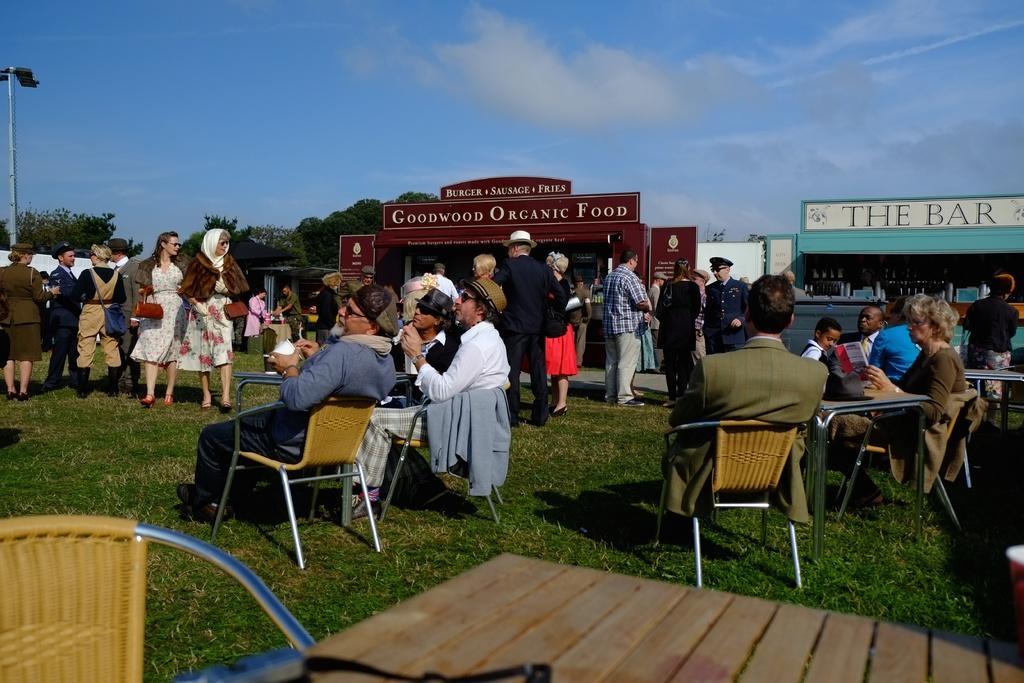How would you summarize this image in a sentence or two? In this picture we can see a group of people on the ground and few people are standing and few people are sitting on chairs and in the background we can see shelters, trees, pole and the sky. 